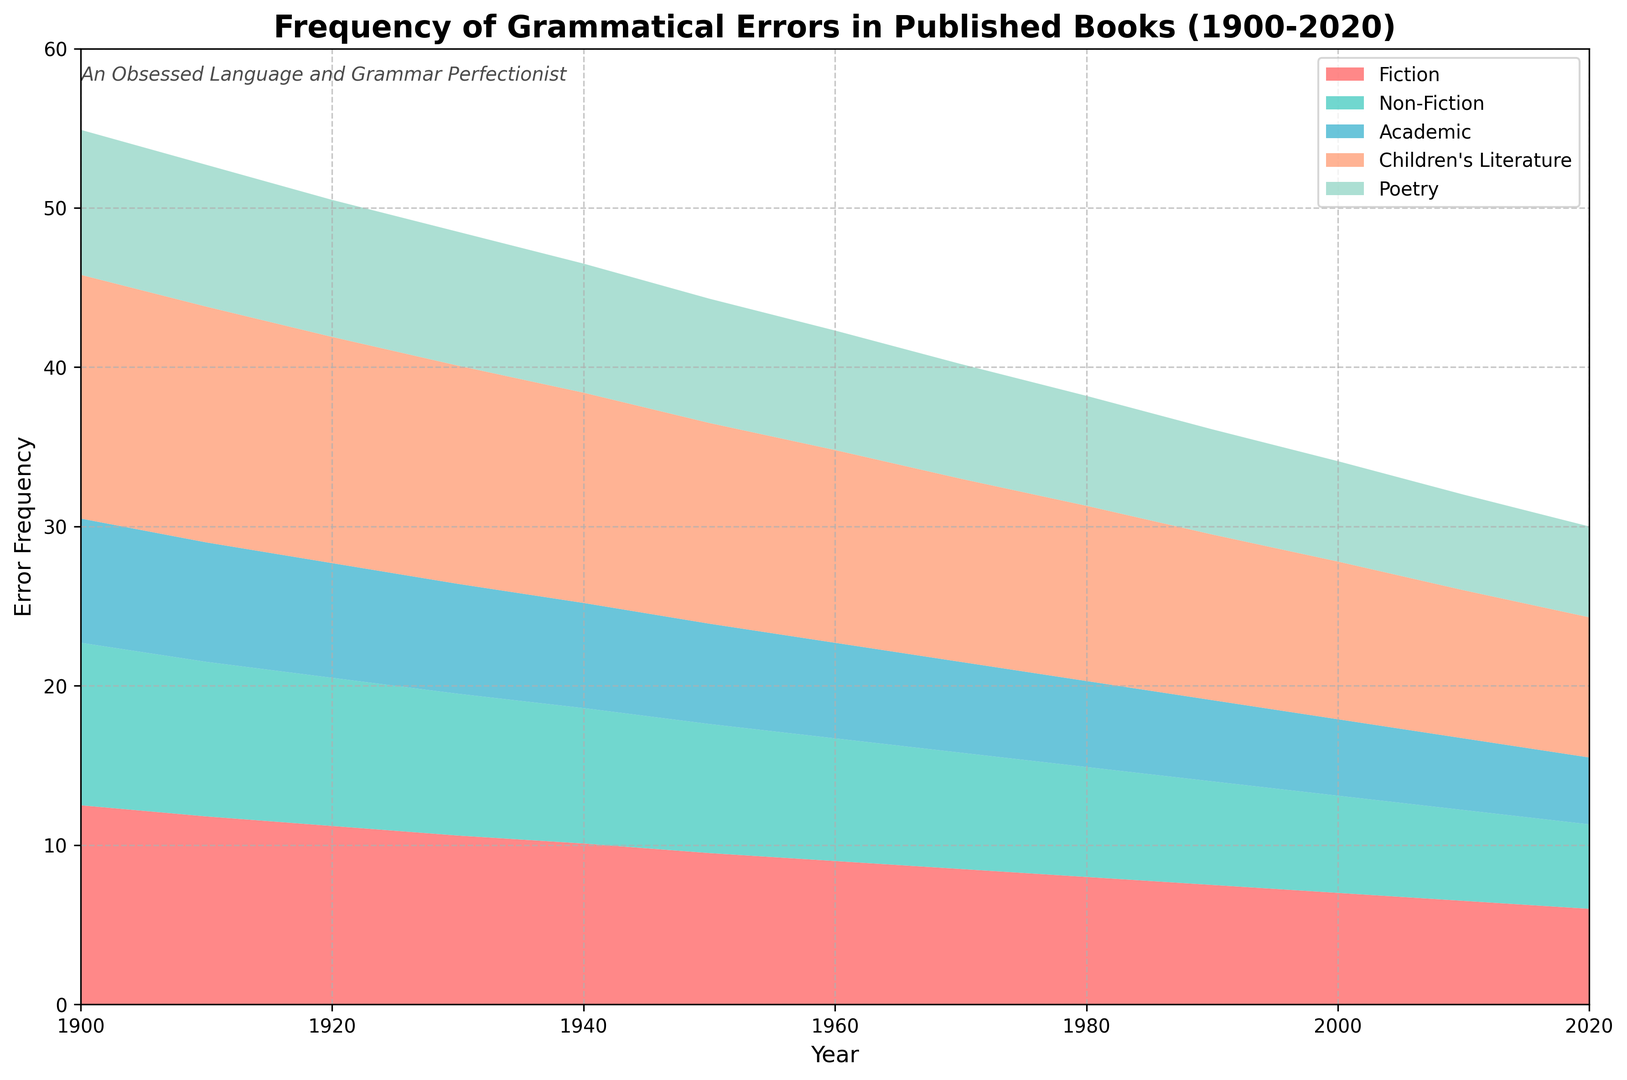What is the frequency of grammatical errors in Fiction books in the year 1920? Locate the line representing Fiction and find the value in 1920. The plot shows that the frequency is 11.2.
Answer: 11.2 Between which years did the frequency of grammatical errors in Children's Literature drop below 10? Find the point on the Children's Literature plot where the frequency drops below 10 and trace the years. The drop happens between 2000 and 2010.
Answer: 2000 - 2010 What is the overall trend for Non-Fiction grammatical errors from 1900 to 2020? Observe the line representing Non-Fiction. The line decreases consistently from about 10.2 in 1900 to 5.3 in 2020, indicating a decreasing trend.
Answer: Decreasing In which decade did Poetry see the most significant drop in grammatical errors? Compare the slopes of the Poetry line segment for each decade. The most significant drop appears between the 1910s (8.9) and the 1920s (8.6).
Answer: 1910s - 1920s Which genre had the highest frequency of grammatical errors in 1950? Compare the values of all genres in 1950. Children's Literature has the highest frequency at 12.6.
Answer: Children’s Literature What is the range of grammatical error frequencies in Fiction over the entire period? Note the highest point (12.5 in 1900) and the lowest point (6.0 in 2020) for Fiction. The range is 12.5 - 6.0 = 6.5.
Answer: 6.5 How many genres had a grammatical error frequency below 8 by 1930? Locate the plot points for each genre in 1930 and count how many are below 8. Non-Fiction (8.9), Academic (6.9), and Poetry (8.4) are below 8.
Answer: 3 In which year did Fiction and Non-Fiction have the same frequency of grammatical errors? Find the intersection of Fiction and Non-Fiction lines. They intersect in 1960.
Answer: 1960 What were the frequencies of grammatical errors in Academic writing in 2000 and 2020, and what is the difference between the two? Read the values from the Academic line in 2000 (4.8) and 2020 (4.2). The difference is 4.8 - 4.2 = 0.6.
Answer: 0.6 